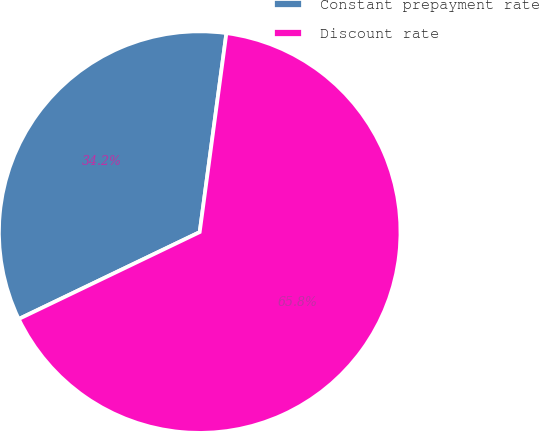<chart> <loc_0><loc_0><loc_500><loc_500><pie_chart><fcel>Constant prepayment rate<fcel>Discount rate<nl><fcel>34.25%<fcel>65.75%<nl></chart> 